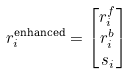Convert formula to latex. <formula><loc_0><loc_0><loc_500><loc_500>r _ { i } ^ { \text {enhanced} } & = \begin{bmatrix} r _ { i } ^ { f } \\ r _ { i } ^ { b } \\ s _ { i } \\ \end{bmatrix}</formula> 